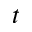<formula> <loc_0><loc_0><loc_500><loc_500>t</formula> 